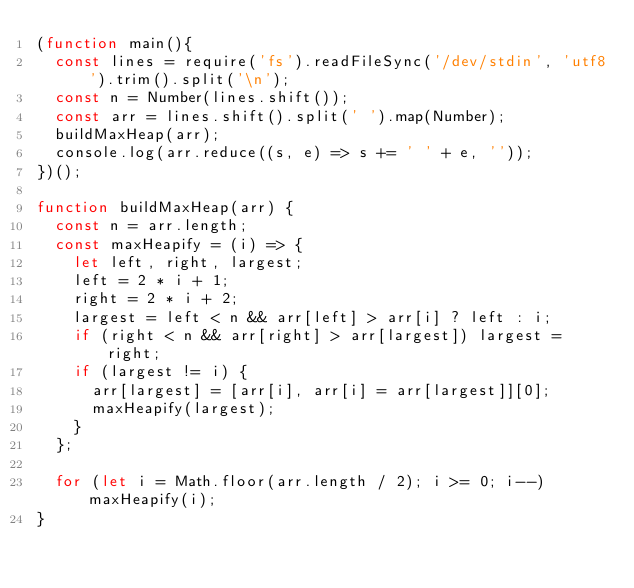<code> <loc_0><loc_0><loc_500><loc_500><_JavaScript_>(function main(){
  const lines = require('fs').readFileSync('/dev/stdin', 'utf8').trim().split('\n');
  const n = Number(lines.shift());
  const arr = lines.shift().split(' ').map(Number);
  buildMaxHeap(arr);
  console.log(arr.reduce((s, e) => s += ' ' + e, ''));
})();

function buildMaxHeap(arr) {
  const n = arr.length;
  const maxHeapify = (i) => {
    let left, right, largest;
    left = 2 * i + 1;
    right = 2 * i + 2;
    largest = left < n && arr[left] > arr[i] ? left : i;
    if (right < n && arr[right] > arr[largest]) largest = right;
    if (largest != i) {
      arr[largest] = [arr[i], arr[i] = arr[largest]][0];
      maxHeapify(largest);
    }
  };

  for (let i = Math.floor(arr.length / 2); i >= 0; i--) maxHeapify(i);
}

</code> 